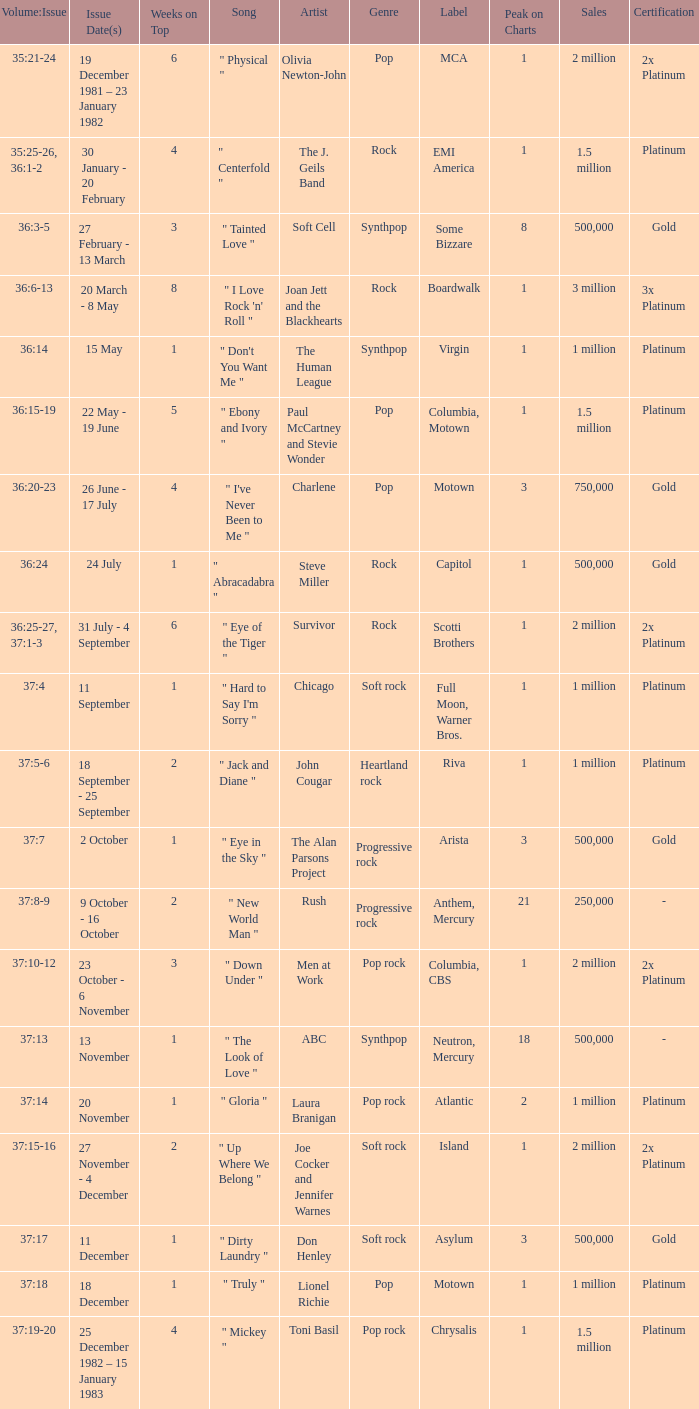Which Weeks on Top have an Issue Date(s) of 20 november? 1.0. 